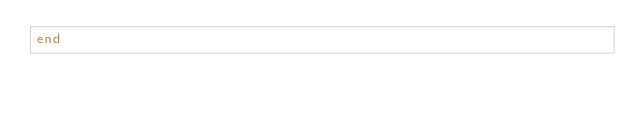Convert code to text. <code><loc_0><loc_0><loc_500><loc_500><_Ruby_>end
</code> 